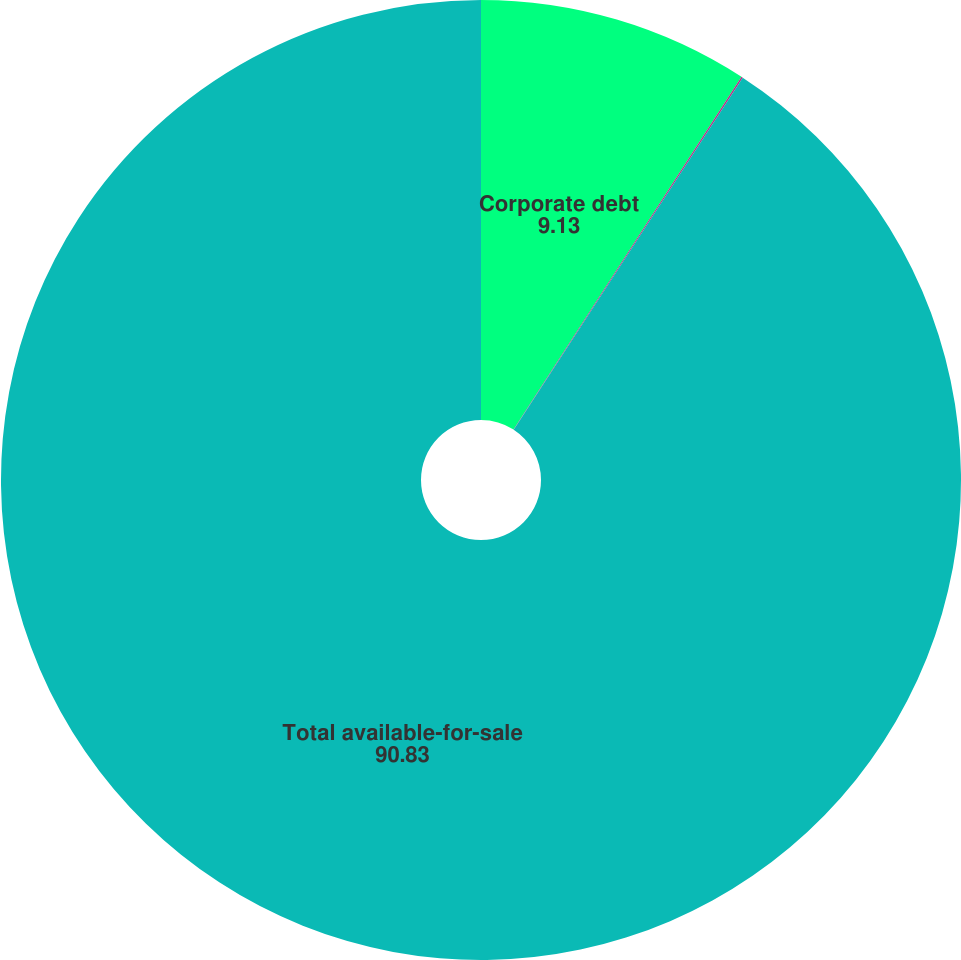Convert chart. <chart><loc_0><loc_0><loc_500><loc_500><pie_chart><fcel>Corporate debt<fcel>Financial institution<fcel>Total available-for-sale<nl><fcel>9.13%<fcel>0.05%<fcel>90.83%<nl></chart> 